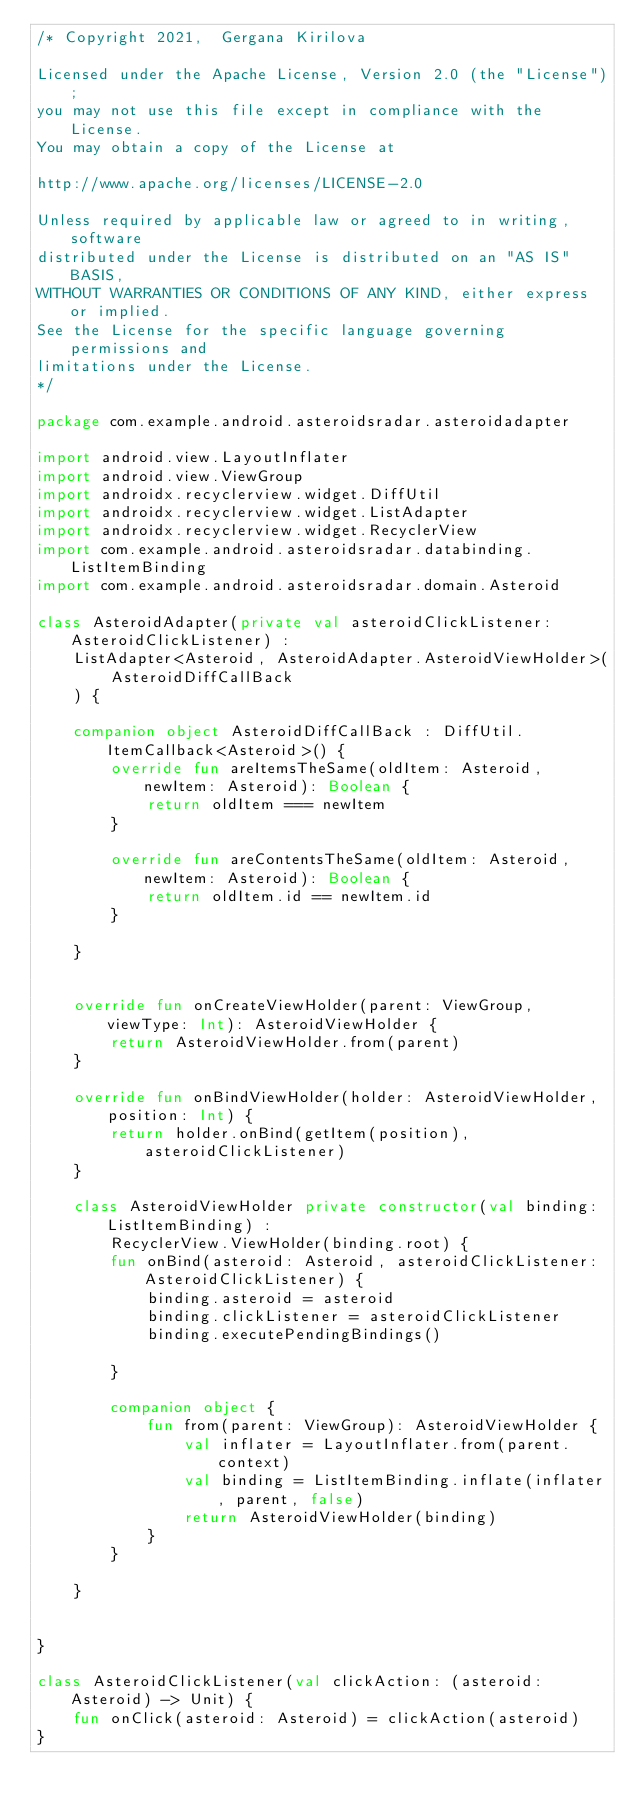<code> <loc_0><loc_0><loc_500><loc_500><_Kotlin_>/* Copyright 2021,  Gergana Kirilova

Licensed under the Apache License, Version 2.0 (the "License");
you may not use this file except in compliance with the License.
You may obtain a copy of the License at

http://www.apache.org/licenses/LICENSE-2.0

Unless required by applicable law or agreed to in writing, software
distributed under the License is distributed on an "AS IS" BASIS,
WITHOUT WARRANTIES OR CONDITIONS OF ANY KIND, either express or implied.
See the License for the specific language governing permissions and
limitations under the License.
*/

package com.example.android.asteroidsradar.asteroidadapter

import android.view.LayoutInflater
import android.view.ViewGroup
import androidx.recyclerview.widget.DiffUtil
import androidx.recyclerview.widget.ListAdapter
import androidx.recyclerview.widget.RecyclerView
import com.example.android.asteroidsradar.databinding.ListItemBinding
import com.example.android.asteroidsradar.domain.Asteroid

class AsteroidAdapter(private val asteroidClickListener: AsteroidClickListener) :
    ListAdapter<Asteroid, AsteroidAdapter.AsteroidViewHolder>(
        AsteroidDiffCallBack
    ) {

    companion object AsteroidDiffCallBack : DiffUtil.ItemCallback<Asteroid>() {
        override fun areItemsTheSame(oldItem: Asteroid, newItem: Asteroid): Boolean {
            return oldItem === newItem
        }

        override fun areContentsTheSame(oldItem: Asteroid, newItem: Asteroid): Boolean {
            return oldItem.id == newItem.id
        }

    }


    override fun onCreateViewHolder(parent: ViewGroup, viewType: Int): AsteroidViewHolder {
        return AsteroidViewHolder.from(parent)
    }

    override fun onBindViewHolder(holder: AsteroidViewHolder, position: Int) {
        return holder.onBind(getItem(position), asteroidClickListener)
    }

    class AsteroidViewHolder private constructor(val binding: ListItemBinding) :
        RecyclerView.ViewHolder(binding.root) {
        fun onBind(asteroid: Asteroid, asteroidClickListener: AsteroidClickListener) {
            binding.asteroid = asteroid
            binding.clickListener = asteroidClickListener
            binding.executePendingBindings()

        }

        companion object {
            fun from(parent: ViewGroup): AsteroidViewHolder {
                val inflater = LayoutInflater.from(parent.context)
                val binding = ListItemBinding.inflate(inflater, parent, false)
                return AsteroidViewHolder(binding)
            }
        }

    }


}

class AsteroidClickListener(val clickAction: (asteroid: Asteroid) -> Unit) {
    fun onClick(asteroid: Asteroid) = clickAction(asteroid)
}
</code> 